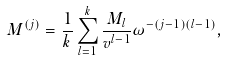Convert formula to latex. <formula><loc_0><loc_0><loc_500><loc_500>M ^ { ( j ) } = \frac { 1 } { k } \sum _ { l = 1 } ^ { k } \frac { M _ { l } } { v ^ { l - 1 } } \omega ^ { - ( j - 1 ) ( l - 1 ) } ,</formula> 